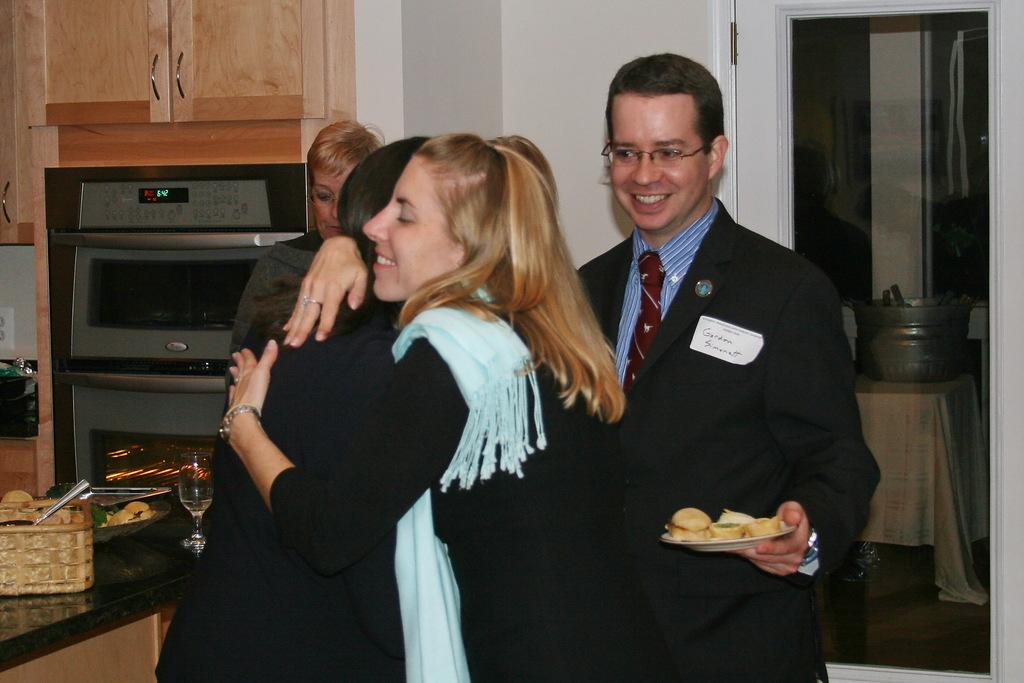<image>
Summarize the visual content of the image. mr gordon simomett smiling behind two people hugging 